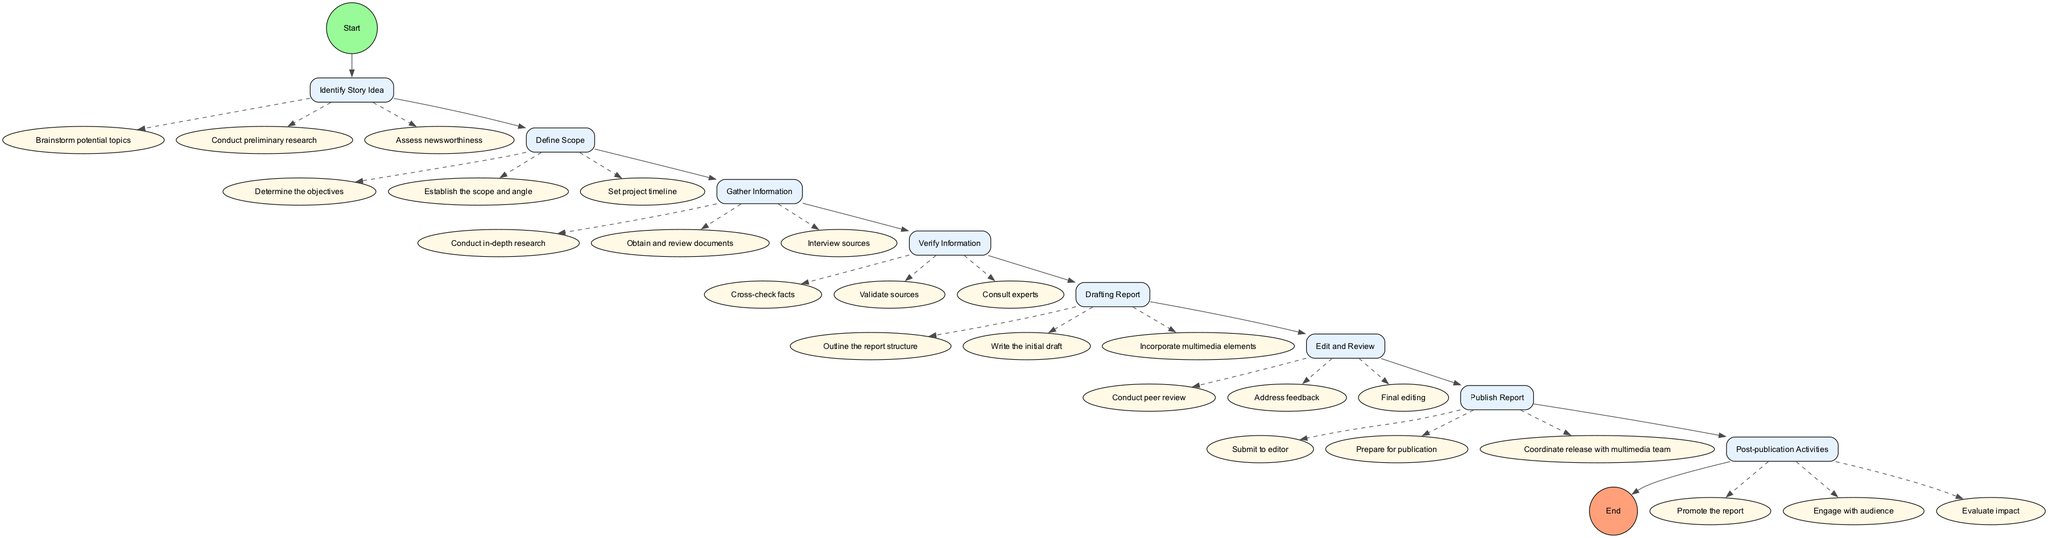What is the first activity in the diagram? The first activity is defined as the initial step after the start node. By reviewing the structure of the diagram, we can identify that the first activity that follows the start node is "Identify Story Idea".
Answer: Identify Story Idea How many actions are associated with the "Gather Information" activity? To determine the number of actions linked with the "Gather Information" activity, we look at the actions listed under it in the diagram. These actions are: "Conduct in-depth research", "Obtain and review documents", and "Interview sources". Therefore, there are three actions.
Answer: 3 What is the last activity before the report is published? To find the last activity prior to publication, we trace the nodes and identify that "Edit and Review" is the activity directly leading to "Publish Report". Thus, the last activity before publication is "Edit and Review".
Answer: Edit and Review How many total activities are there in the diagram? The total number of activities can be found by counting all the individual activities listed in the diagram. Each of the activities from start to end comprises eight in total: "Identify Story Idea", "Define Scope", "Gather Information", "Verify Information", "Drafting Report", "Edit and Review", "Publish Report", and "Post-publication Activities".
Answer: 8 What type of relationship exists between "Drafting Report" and "Edit and Review" activities? The relationship between "Drafting Report" and "Edit and Review" can be identified as sequential. After completing the "Drafting Report" activity, the next step in the process as shown in the diagram is "Edit and Review".
Answer: Sequential Which action is performed last in the investigative reporting process? To determine which action is last, we follow the activities and actions in order leading to the end node. The last action listed following "Post-publication Activities" is "Evaluate impact". Therefore, this is identified as the last action in the process.
Answer: Evaluate impact 